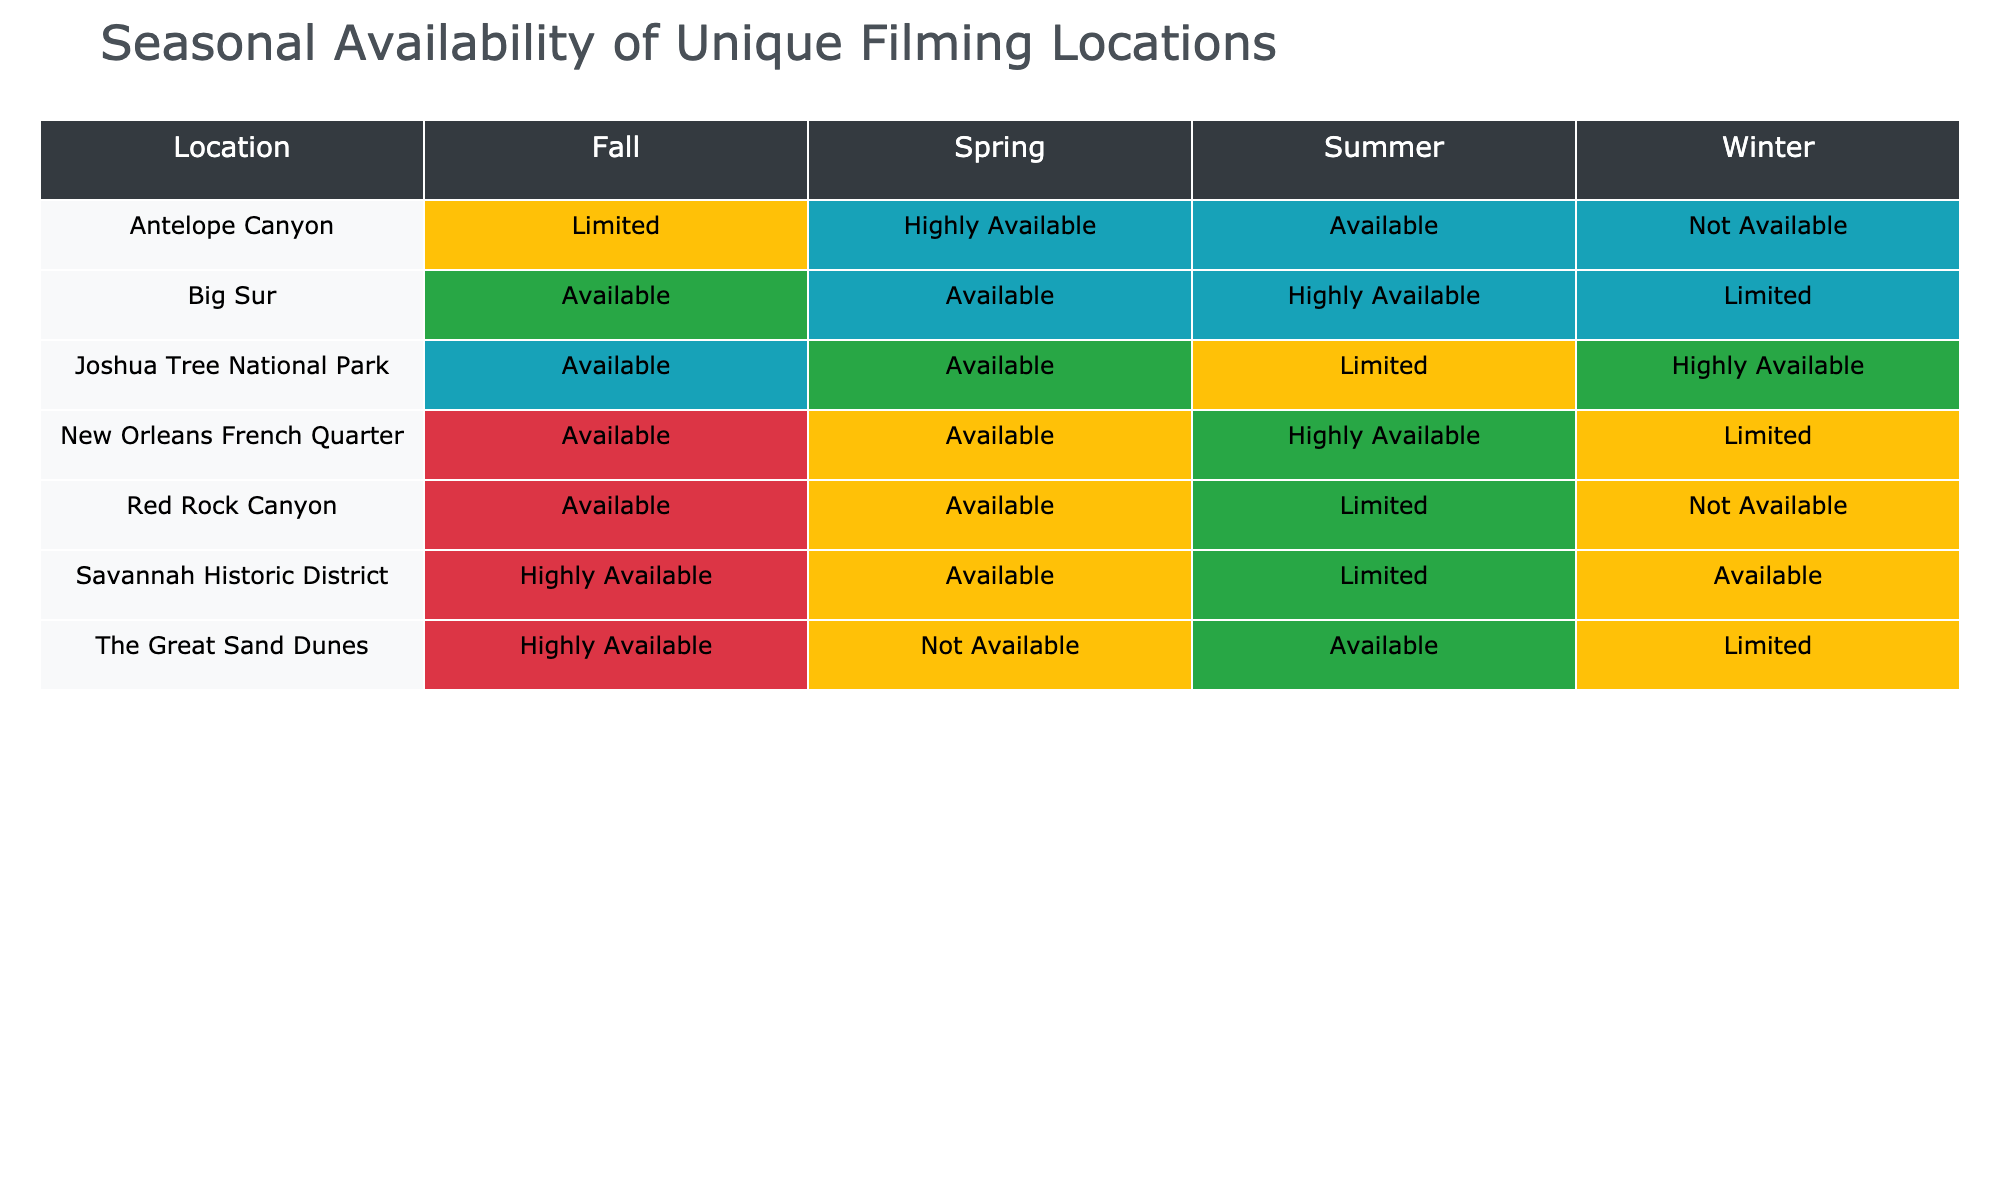What is the availability of Big Sur in Spring? The table indicates that the availability of Big Sur during the Spring season is listed as "Available."
Answer: Available Which location has the highest availability in Summer? Comparing the Summer availability for each location, Big Sur has "Highly Available," which is the highest rating among all entries.
Answer: Big Sur Is The Great Sand Dunes available in Fall? The table shows that The Great Sand Dunes has the availability marked as "Highly Available" for the Fall season, confirming that it is indeed available during this time.
Answer: Yes What is the combined availability for Antelope Canyon across all seasons? Antelope Canyon has "Highly Available" in Spring, "Available" in Summer, "Limited" in Fall, and "Not Available" in Winter. Counting the available seasons (3 out of 4), we conclude that it is combined available in 3 seasons.
Answer: 3 seasons Which locations are not available in Winter? The table lists Red Rock Canyon and Antelope Canyon as "Not Available" in the Winter season. Therefore, these are the locations that are not available in this season.
Answer: Red Rock Canyon, Antelope Canyon What is the difference in availability between Summer and Winter for Joshua Tree National Park? In Summer, Joshua Tree has "Limited" availability, whereas in Winter it is "Highly Available." The numerical difference between the two qualitative ratings shows a shift from limited to highly available, indicating an improvement of 2 levels.
Answer: Improvement of 2 levels Do any locations have Limited availability in both Summer and Winter? The table confirms that Joshua Tree National Park has "Limited" availability in Summer, while Red Rock Canyon has "Limited" availability in Summer and does not have any data related to Winter. After analyzing the data thoroughly, it's clear that Joshua Tree National Park holds this characteristic.
Answer: Yes What percentage of locations are available in Fall? The locations and their Fall availability are: Red Rock Canyon (Available), Big Sur (Available), The Great Sand Dunes (Highly Available), Antelope Canyon (Limited), Savannah Historic District (Highly Available), New Orleans French Quarter (Available), and Joshua Tree National Park (Available). This totals 7 available locations out of 7 total locations, resulting in a percentage of 100% availability in Fall.
Answer: 100% What locations have Limited availability in Summer? Referring to the table, the locations that have "Limited" availability in Summer are Red Rock Canyon and Joshua Tree National Park.
Answer: Red Rock Canyon, Joshua Tree National Park 